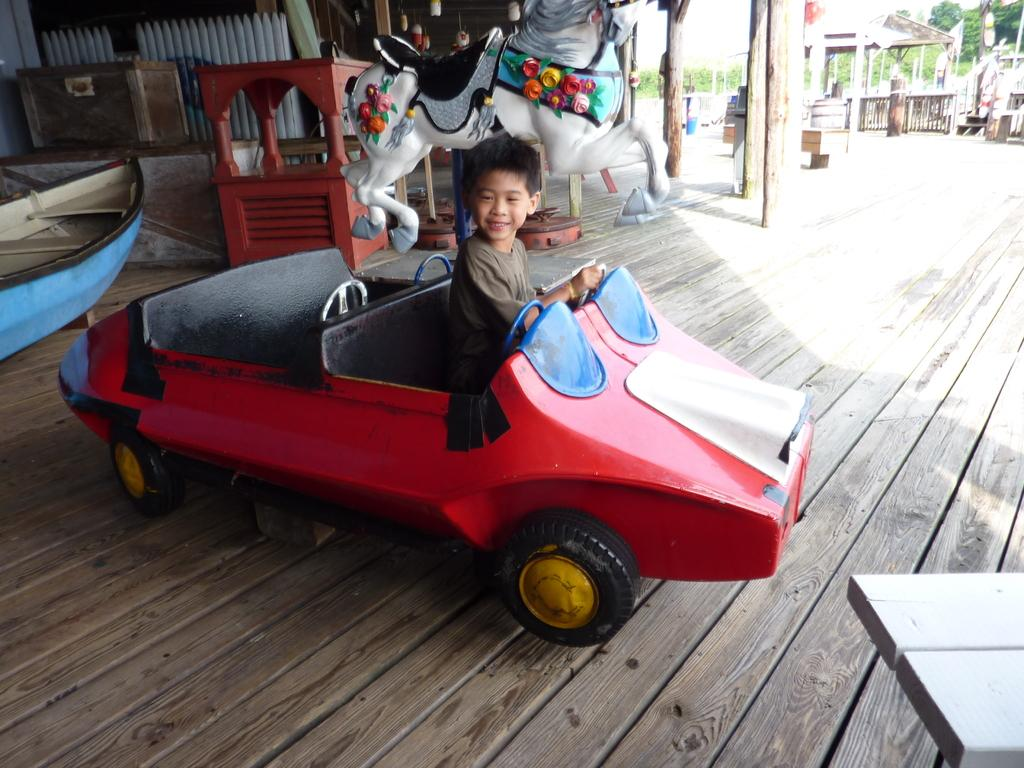Who is the main subject in the image? There is a little boy in the image. What is the boy doing in the image? The boy is sitting in a toy car and playing. What color is the toy car the boy is sitting in? The toy car is red in color. What type of popcorn is the boy eating while sitting in the toy car? There is no popcorn present in the image; the boy is simply playing in the red toy car. 